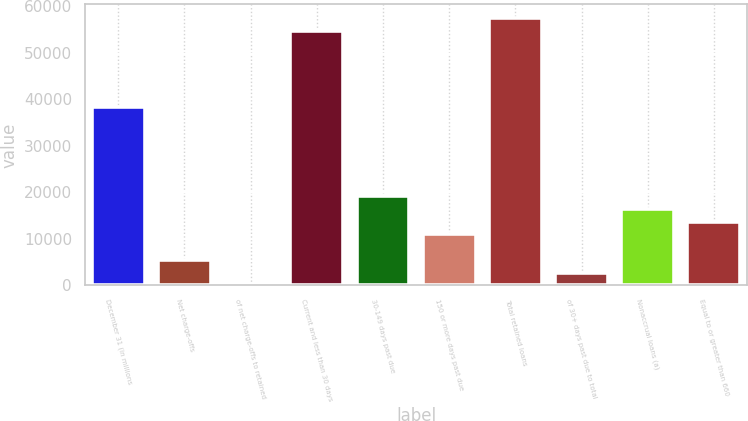Convert chart. <chart><loc_0><loc_0><loc_500><loc_500><bar_chart><fcel>December 31 (in millions<fcel>Net charge-offs<fcel>of net charge-offs to retained<fcel>Current and less than 30 days<fcel>30-149 days past due<fcel>150 or more days past due<fcel>Total retained loans<fcel>of 30+ days past due to total<fcel>Nonaccrual loans (a)<fcel>Equal to or greater than 660<nl><fcel>38326.1<fcel>5475.84<fcel>0.8<fcel>54751.2<fcel>19163.4<fcel>10950.9<fcel>57488.7<fcel>2738.32<fcel>16425.9<fcel>13688.4<nl></chart> 